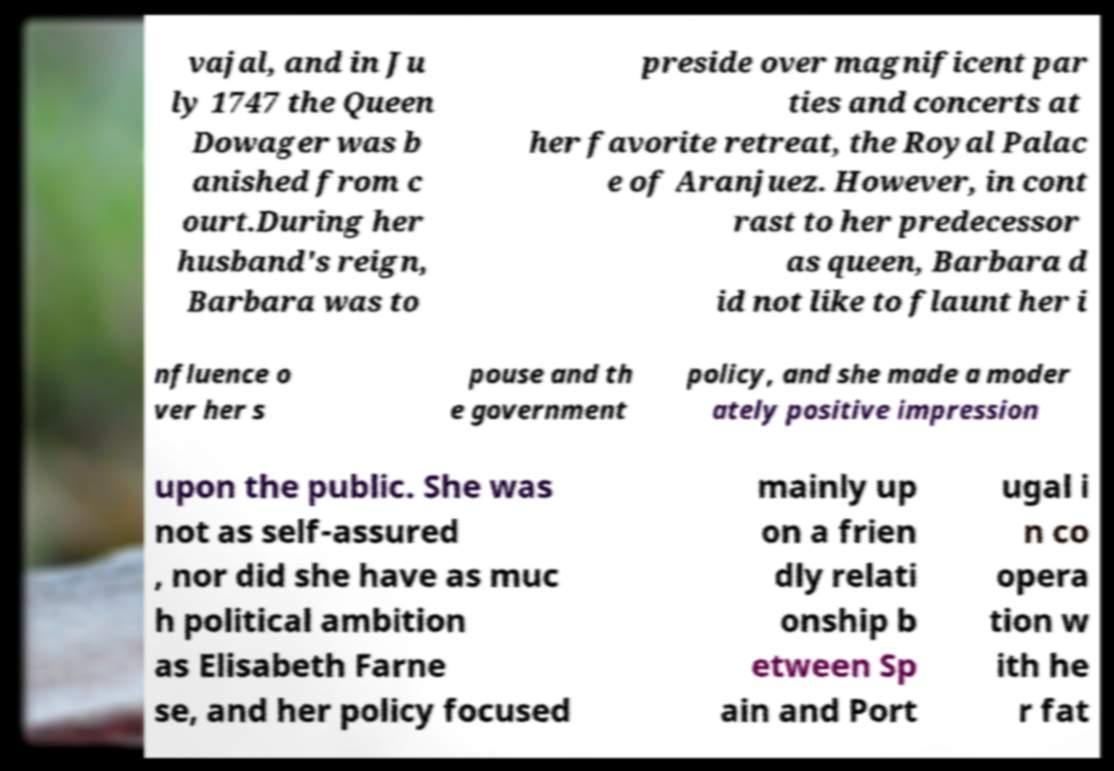I need the written content from this picture converted into text. Can you do that? vajal, and in Ju ly 1747 the Queen Dowager was b anished from c ourt.During her husband's reign, Barbara was to preside over magnificent par ties and concerts at her favorite retreat, the Royal Palac e of Aranjuez. However, in cont rast to her predecessor as queen, Barbara d id not like to flaunt her i nfluence o ver her s pouse and th e government policy, and she made a moder ately positive impression upon the public. She was not as self-assured , nor did she have as muc h political ambition as Elisabeth Farne se, and her policy focused mainly up on a frien dly relati onship b etween Sp ain and Port ugal i n co opera tion w ith he r fat 